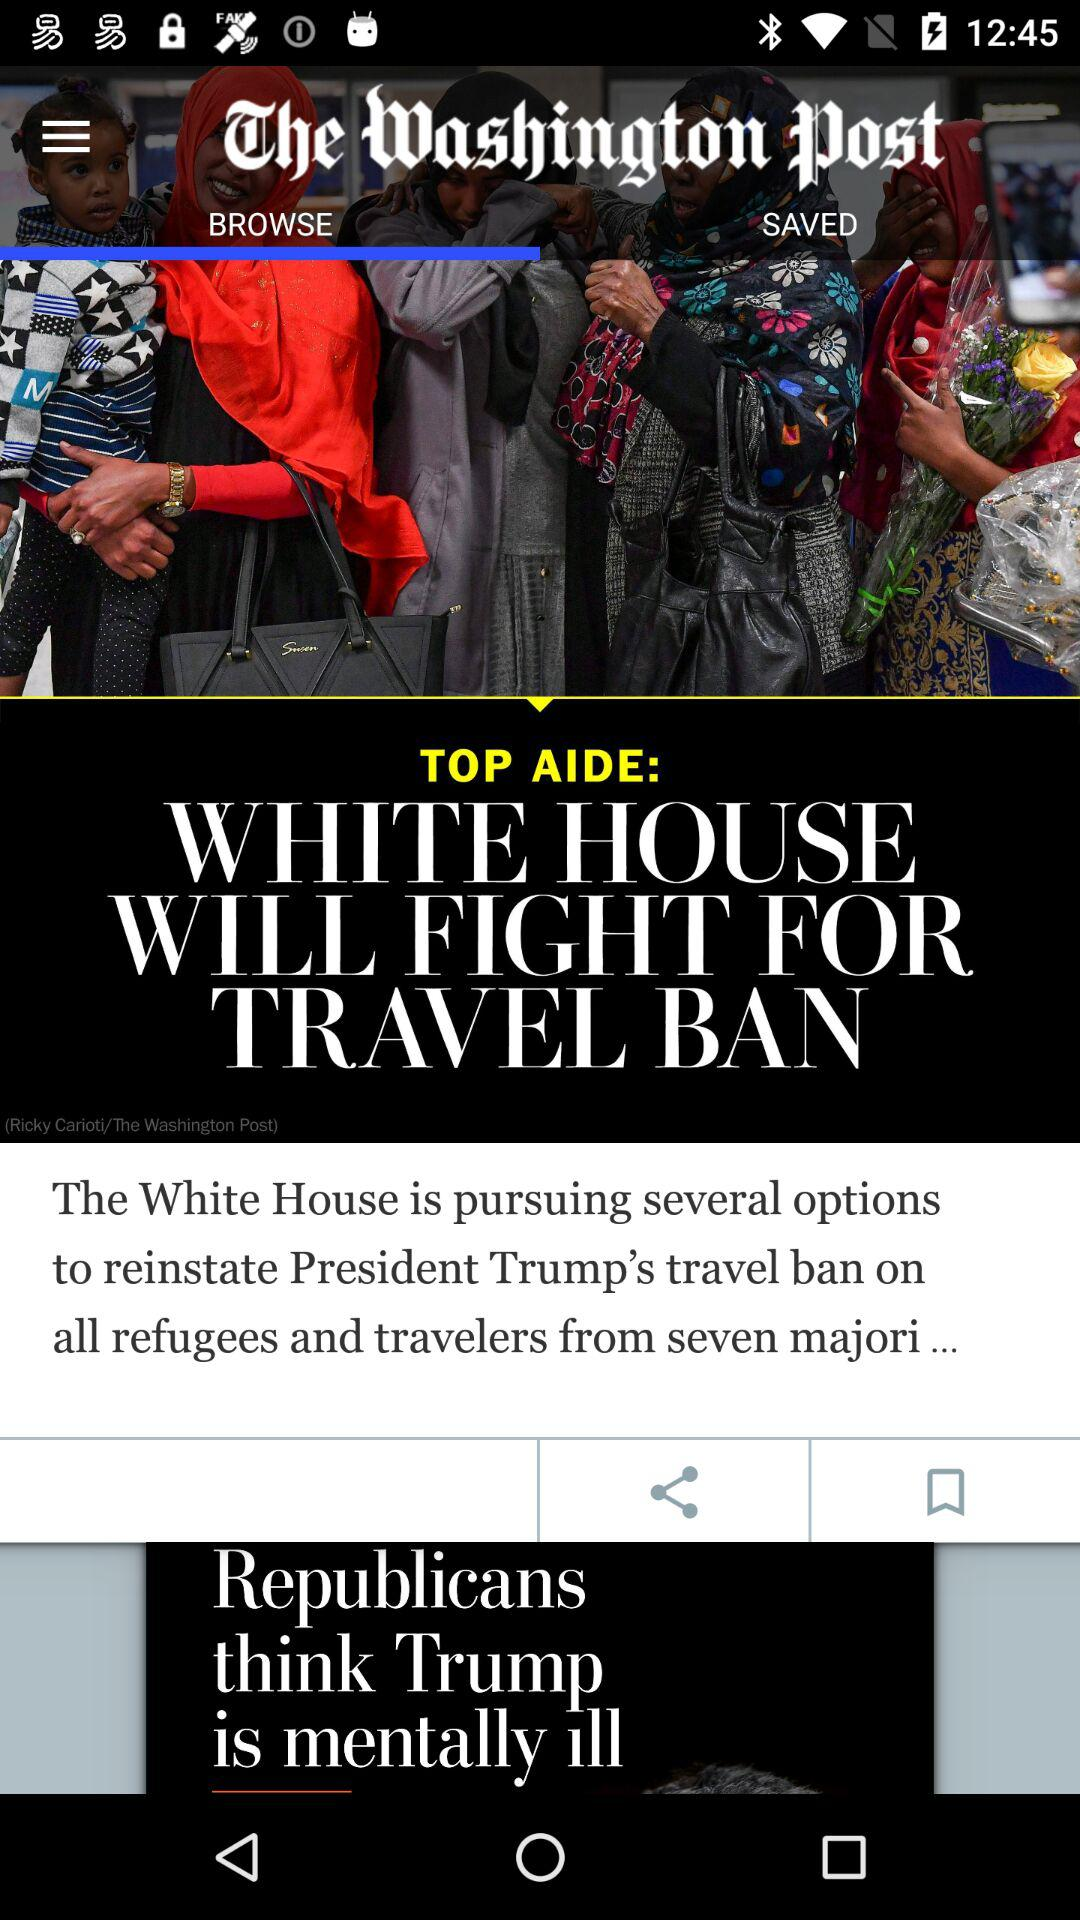Which tab has been selected? The tab that has been selected is "BROWSE". 